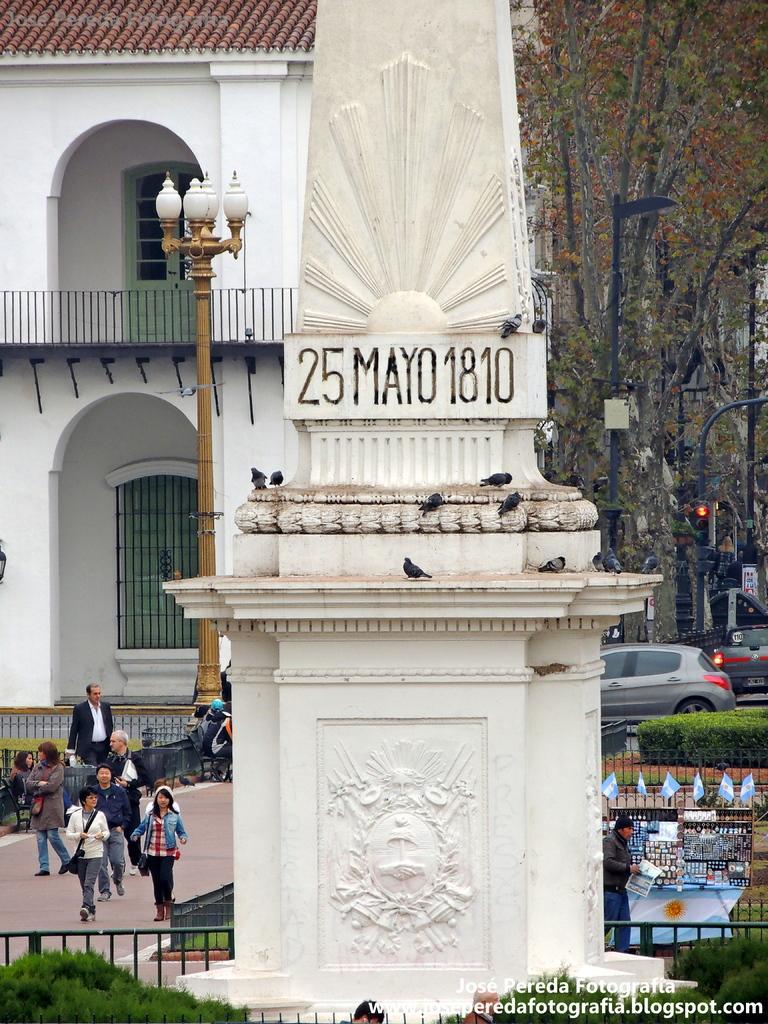Could you give a brief overview of what you see in this image? In the image we can see in front there is a statue, behind there are people standing on the footpath. There are cars parked on the road and there are trees and there is a building at the back. 